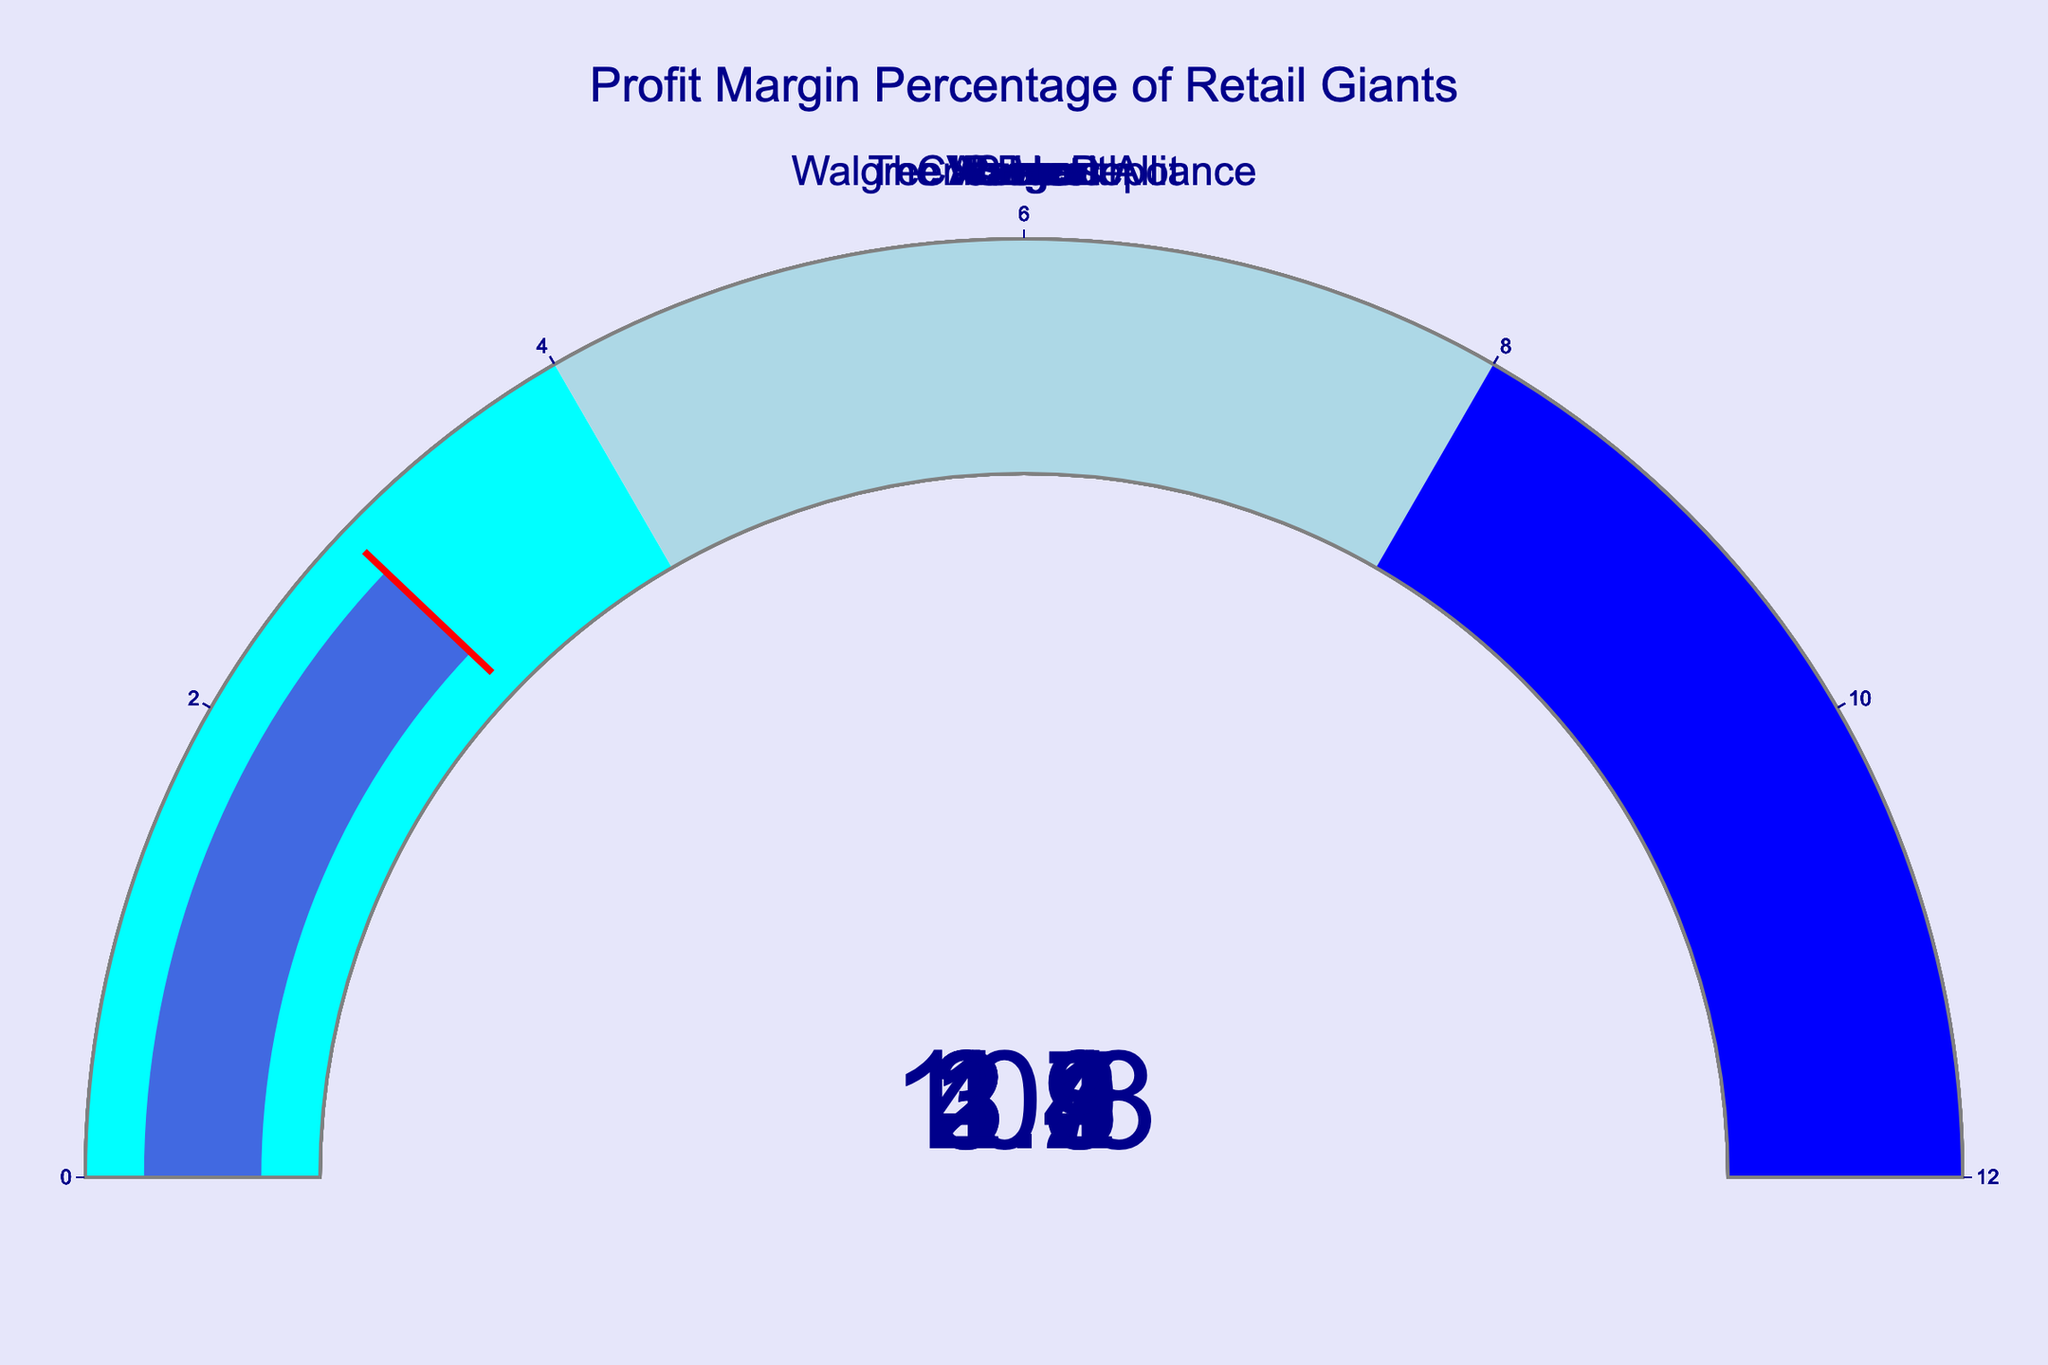What is the profit margin percentage of Walmart? Walmart's gauge shows a number indicating its profit margin percentage. It is labeled "Walmart" in the figure and the gauge needle indicates the value.
Answer: 2.3% Which company has the highest profit margin percentage? By looking at each gauge, we identify the company with the highest number on the gauge display. The Home Depot has the highest value.
Answer: The Home Depot What is the average profit margin percentage of Costco and Kroger? The profit margin percentage for Costco is 2.4% and for Kroger is 1.2%. Average = (2.4 + 1.2) / 2.
Answer: 1.8% How does Target's profit margin percentage compare to Walgreens Boots Alliance? Target's gauge shows 4.7% while Walgreens Boots Alliance shows 3.1%. Thus, Target's profit margin is higher.
Answer: Target's is higher Which companies have a profit margin percentage below 3%? By checking the numbers on each gauge, the companies below 3% are Walmart, Costco, Kroger, and CVS Health.
Answer: Walmart, Costco, Kroger, CVS Health What's the difference in profit margin percentages between Amazon and Target? Amazon's profit margin is 3.8% and Target's is 4.7%. Difference = 4.7 - 3.8.
Answer: 0.9% How many companies have profit margins over 5%? By scanning the gauges, only The Home Depot has a profit margin above 5%.
Answer: One company (The Home Depot) What is the range of profit margin percentages represented in the figure? The lowest percentage is Kroger with 1.2% and the highest is The Home Depot with 10.8%. The range is 10.8% - 1.2%.
Answer: 9.6% In which color range does Amazon's profit margin fall? The gauge colors are cyan (0-4%), light blue (4-8%), and blue (8-12%). Amazon's profit margin is 3.8%, which falls into the cyan range.
Answer: Cyan What percentage of companies have a profit margin below 3%? There are 8 companies in total. The companies with margins below 3% are Walmart, Costco, Kroger, and CVS Health, which totals 4. Percentage = (4/8) * 100%.
Answer: 50% 